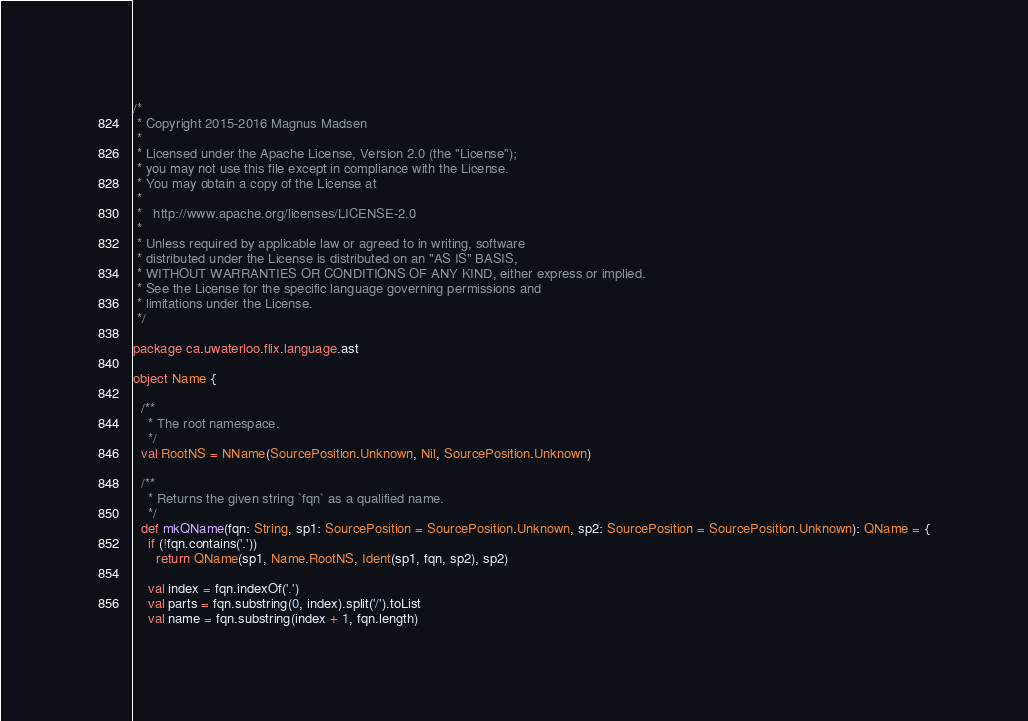Convert code to text. <code><loc_0><loc_0><loc_500><loc_500><_Scala_>/*
 * Copyright 2015-2016 Magnus Madsen
 *
 * Licensed under the Apache License, Version 2.0 (the "License");
 * you may not use this file except in compliance with the License.
 * You may obtain a copy of the License at
 *
 *   http://www.apache.org/licenses/LICENSE-2.0
 *
 * Unless required by applicable law or agreed to in writing, software
 * distributed under the License is distributed on an "AS IS" BASIS,
 * WITHOUT WARRANTIES OR CONDITIONS OF ANY KIND, either express or implied.
 * See the License for the specific language governing permissions and
 * limitations under the License.
 */

package ca.uwaterloo.flix.language.ast

object Name {

  /**
    * The root namespace.
    */
  val RootNS = NName(SourcePosition.Unknown, Nil, SourcePosition.Unknown)

  /**
    * Returns the given string `fqn` as a qualified name.
    */
  def mkQName(fqn: String, sp1: SourcePosition = SourcePosition.Unknown, sp2: SourcePosition = SourcePosition.Unknown): QName = {
    if (!fqn.contains('.'))
      return QName(sp1, Name.RootNS, Ident(sp1, fqn, sp2), sp2)

    val index = fqn.indexOf('.')
    val parts = fqn.substring(0, index).split('/').toList
    val name = fqn.substring(index + 1, fqn.length)</code> 